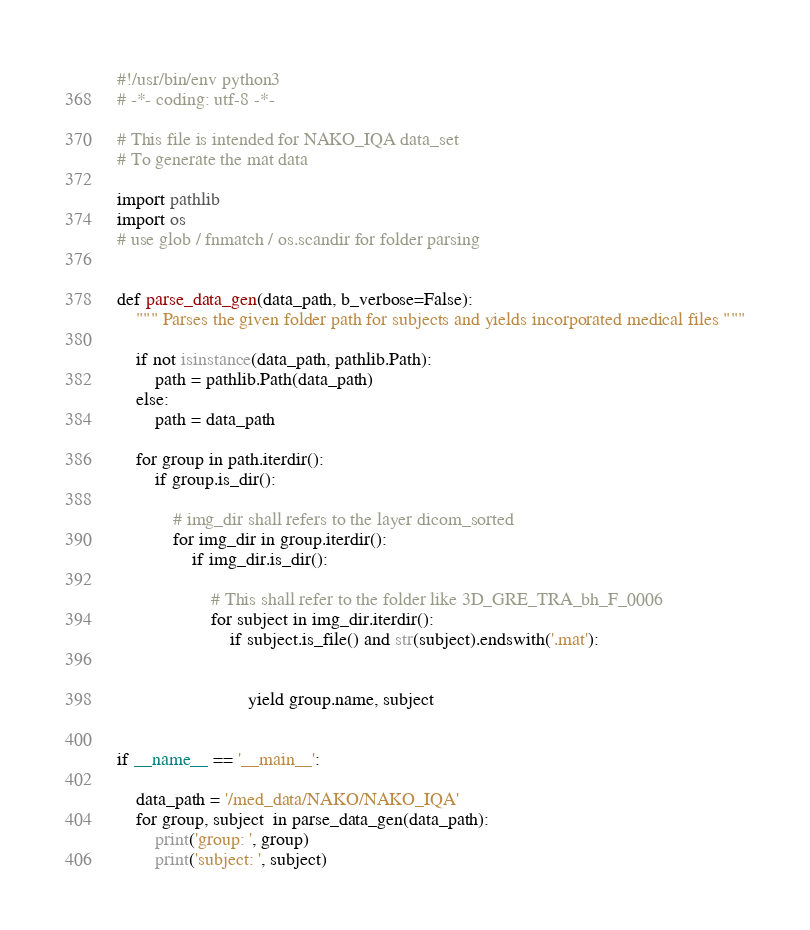<code> <loc_0><loc_0><loc_500><loc_500><_Python_>#!/usr/bin/env python3
# -*- coding: utf-8 -*-

# This file is intended for NAKO_IQA data_set
# To generate the mat data

import pathlib
import os
# use glob / fnmatch / os.scandir for folder parsing


def parse_data_gen(data_path, b_verbose=False):
    """ Parses the given folder path for subjects and yields incorporated medical files """

    if not isinstance(data_path, pathlib.Path):
        path = pathlib.Path(data_path)
    else:
        path = data_path

    for group in path.iterdir():
        if group.is_dir():

            # img_dir shall refers to the layer dicom_sorted
            for img_dir in group.iterdir():
                if img_dir.is_dir():

                    # This shall refer to the folder like 3D_GRE_TRA_bh_F_0006
                    for subject in img_dir.iterdir():
                        if subject.is_file() and str(subject).endswith('.mat'):


                            yield group.name, subject


if __name__ == '__main__':

    data_path = '/med_data/NAKO/NAKO_IQA'
    for group, subject  in parse_data_gen(data_path):
        print('group: ', group)
        print('subject: ', subject)</code> 